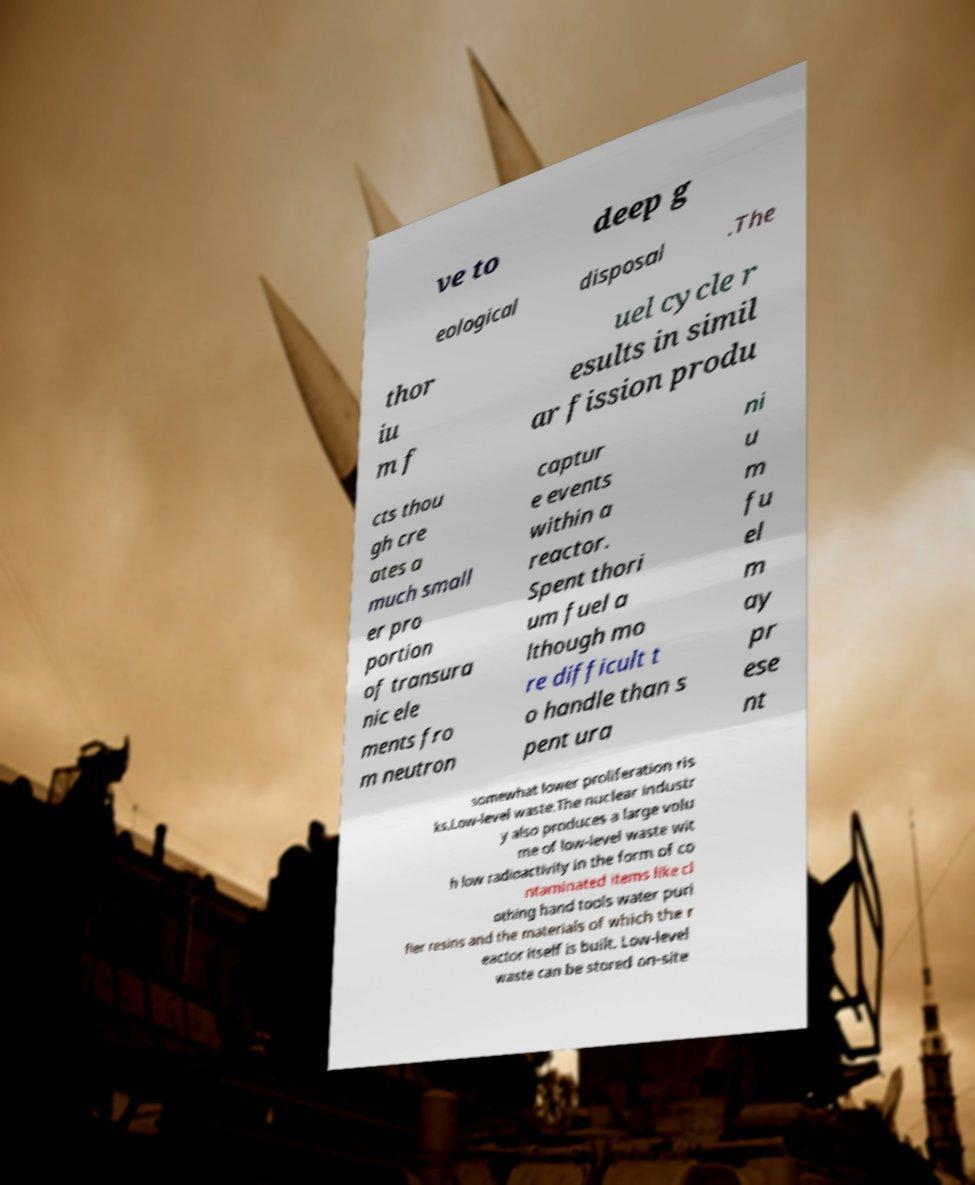For documentation purposes, I need the text within this image transcribed. Could you provide that? ve to deep g eological disposal .The thor iu m f uel cycle r esults in simil ar fission produ cts thou gh cre ates a much small er pro portion of transura nic ele ments fro m neutron captur e events within a reactor. Spent thori um fuel a lthough mo re difficult t o handle than s pent ura ni u m fu el m ay pr ese nt somewhat lower proliferation ris ks.Low-level waste.The nuclear industr y also produces a large volu me of low-level waste wit h low radioactivity in the form of co ntaminated items like cl othing hand tools water puri fier resins and the materials of which the r eactor itself is built. Low-level waste can be stored on-site 